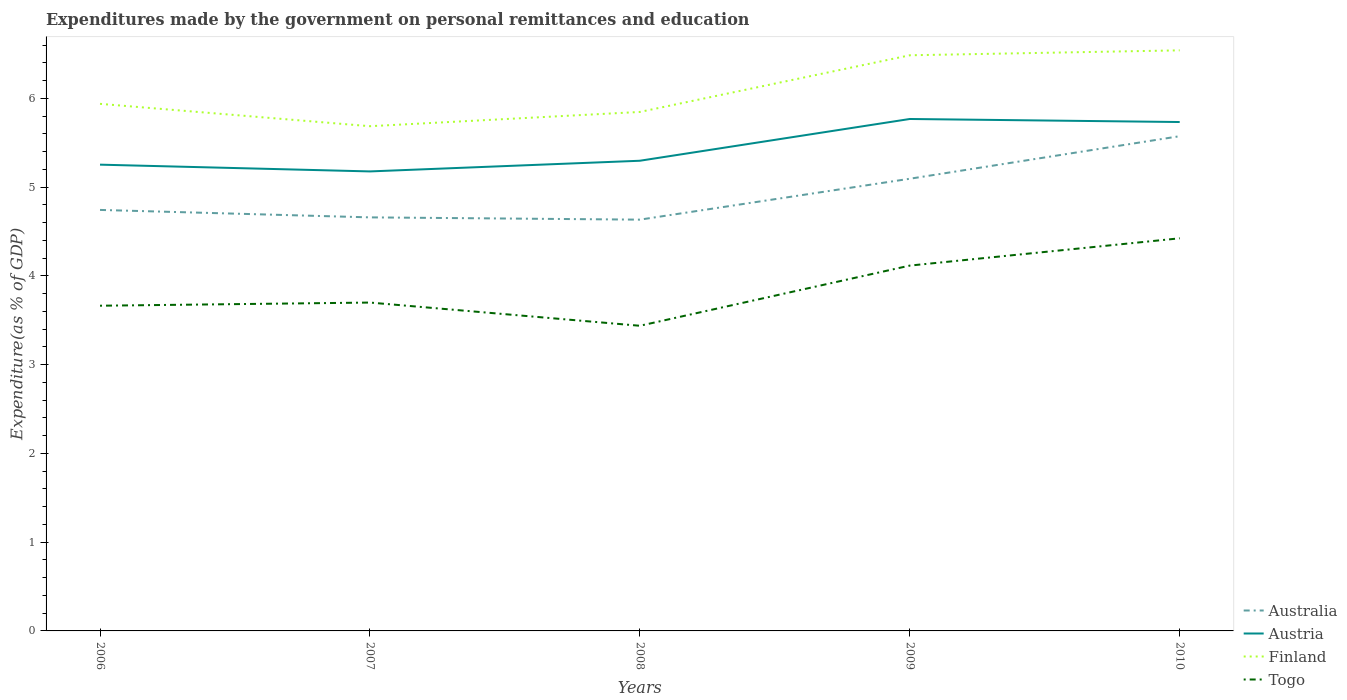How many different coloured lines are there?
Give a very brief answer. 4. Does the line corresponding to Austria intersect with the line corresponding to Togo?
Your answer should be compact. No. Is the number of lines equal to the number of legend labels?
Provide a short and direct response. Yes. Across all years, what is the maximum expenditures made by the government on personal remittances and education in Finland?
Ensure brevity in your answer.  5.69. In which year was the expenditures made by the government on personal remittances and education in Finland maximum?
Make the answer very short. 2007. What is the total expenditures made by the government on personal remittances and education in Finland in the graph?
Offer a very short reply. -0.6. What is the difference between the highest and the second highest expenditures made by the government on personal remittances and education in Australia?
Provide a succinct answer. 0.94. What is the difference between the highest and the lowest expenditures made by the government on personal remittances and education in Austria?
Provide a succinct answer. 2. How many lines are there?
Ensure brevity in your answer.  4. How many years are there in the graph?
Provide a succinct answer. 5. What is the difference between two consecutive major ticks on the Y-axis?
Offer a terse response. 1. Does the graph contain any zero values?
Your answer should be compact. No. Does the graph contain grids?
Provide a succinct answer. No. Where does the legend appear in the graph?
Your answer should be compact. Bottom right. How many legend labels are there?
Your response must be concise. 4. What is the title of the graph?
Provide a succinct answer. Expenditures made by the government on personal remittances and education. What is the label or title of the Y-axis?
Your answer should be compact. Expenditure(as % of GDP). What is the Expenditure(as % of GDP) of Australia in 2006?
Keep it short and to the point. 4.74. What is the Expenditure(as % of GDP) in Austria in 2006?
Provide a short and direct response. 5.25. What is the Expenditure(as % of GDP) of Finland in 2006?
Your answer should be compact. 5.94. What is the Expenditure(as % of GDP) in Togo in 2006?
Provide a short and direct response. 3.66. What is the Expenditure(as % of GDP) of Australia in 2007?
Your answer should be compact. 4.66. What is the Expenditure(as % of GDP) of Austria in 2007?
Offer a very short reply. 5.18. What is the Expenditure(as % of GDP) of Finland in 2007?
Give a very brief answer. 5.69. What is the Expenditure(as % of GDP) in Togo in 2007?
Provide a short and direct response. 3.7. What is the Expenditure(as % of GDP) in Australia in 2008?
Ensure brevity in your answer.  4.63. What is the Expenditure(as % of GDP) in Austria in 2008?
Offer a terse response. 5.3. What is the Expenditure(as % of GDP) of Finland in 2008?
Provide a succinct answer. 5.85. What is the Expenditure(as % of GDP) in Togo in 2008?
Give a very brief answer. 3.44. What is the Expenditure(as % of GDP) in Australia in 2009?
Your answer should be compact. 5.09. What is the Expenditure(as % of GDP) of Austria in 2009?
Make the answer very short. 5.77. What is the Expenditure(as % of GDP) of Finland in 2009?
Keep it short and to the point. 6.49. What is the Expenditure(as % of GDP) of Togo in 2009?
Your answer should be compact. 4.12. What is the Expenditure(as % of GDP) in Australia in 2010?
Offer a very short reply. 5.57. What is the Expenditure(as % of GDP) of Austria in 2010?
Keep it short and to the point. 5.73. What is the Expenditure(as % of GDP) in Finland in 2010?
Offer a terse response. 6.54. What is the Expenditure(as % of GDP) in Togo in 2010?
Give a very brief answer. 4.42. Across all years, what is the maximum Expenditure(as % of GDP) of Australia?
Your response must be concise. 5.57. Across all years, what is the maximum Expenditure(as % of GDP) of Austria?
Offer a very short reply. 5.77. Across all years, what is the maximum Expenditure(as % of GDP) in Finland?
Ensure brevity in your answer.  6.54. Across all years, what is the maximum Expenditure(as % of GDP) of Togo?
Offer a terse response. 4.42. Across all years, what is the minimum Expenditure(as % of GDP) of Australia?
Give a very brief answer. 4.63. Across all years, what is the minimum Expenditure(as % of GDP) in Austria?
Provide a succinct answer. 5.18. Across all years, what is the minimum Expenditure(as % of GDP) of Finland?
Provide a succinct answer. 5.69. Across all years, what is the minimum Expenditure(as % of GDP) in Togo?
Offer a terse response. 3.44. What is the total Expenditure(as % of GDP) of Australia in the graph?
Your answer should be compact. 24.7. What is the total Expenditure(as % of GDP) in Austria in the graph?
Give a very brief answer. 27.23. What is the total Expenditure(as % of GDP) in Finland in the graph?
Offer a very short reply. 30.5. What is the total Expenditure(as % of GDP) of Togo in the graph?
Your response must be concise. 19.34. What is the difference between the Expenditure(as % of GDP) in Australia in 2006 and that in 2007?
Keep it short and to the point. 0.08. What is the difference between the Expenditure(as % of GDP) in Austria in 2006 and that in 2007?
Your answer should be very brief. 0.08. What is the difference between the Expenditure(as % of GDP) of Finland in 2006 and that in 2007?
Give a very brief answer. 0.25. What is the difference between the Expenditure(as % of GDP) of Togo in 2006 and that in 2007?
Offer a very short reply. -0.04. What is the difference between the Expenditure(as % of GDP) of Australia in 2006 and that in 2008?
Make the answer very short. 0.11. What is the difference between the Expenditure(as % of GDP) in Austria in 2006 and that in 2008?
Your response must be concise. -0.04. What is the difference between the Expenditure(as % of GDP) in Finland in 2006 and that in 2008?
Provide a short and direct response. 0.09. What is the difference between the Expenditure(as % of GDP) in Togo in 2006 and that in 2008?
Offer a terse response. 0.23. What is the difference between the Expenditure(as % of GDP) in Australia in 2006 and that in 2009?
Your answer should be compact. -0.35. What is the difference between the Expenditure(as % of GDP) in Austria in 2006 and that in 2009?
Provide a short and direct response. -0.51. What is the difference between the Expenditure(as % of GDP) in Finland in 2006 and that in 2009?
Your answer should be compact. -0.55. What is the difference between the Expenditure(as % of GDP) in Togo in 2006 and that in 2009?
Make the answer very short. -0.45. What is the difference between the Expenditure(as % of GDP) in Australia in 2006 and that in 2010?
Keep it short and to the point. -0.83. What is the difference between the Expenditure(as % of GDP) of Austria in 2006 and that in 2010?
Provide a succinct answer. -0.48. What is the difference between the Expenditure(as % of GDP) in Finland in 2006 and that in 2010?
Keep it short and to the point. -0.6. What is the difference between the Expenditure(as % of GDP) in Togo in 2006 and that in 2010?
Offer a terse response. -0.76. What is the difference between the Expenditure(as % of GDP) of Australia in 2007 and that in 2008?
Provide a short and direct response. 0.03. What is the difference between the Expenditure(as % of GDP) of Austria in 2007 and that in 2008?
Give a very brief answer. -0.12. What is the difference between the Expenditure(as % of GDP) in Finland in 2007 and that in 2008?
Ensure brevity in your answer.  -0.16. What is the difference between the Expenditure(as % of GDP) in Togo in 2007 and that in 2008?
Offer a very short reply. 0.26. What is the difference between the Expenditure(as % of GDP) in Australia in 2007 and that in 2009?
Your answer should be very brief. -0.44. What is the difference between the Expenditure(as % of GDP) in Austria in 2007 and that in 2009?
Give a very brief answer. -0.59. What is the difference between the Expenditure(as % of GDP) in Finland in 2007 and that in 2009?
Keep it short and to the point. -0.8. What is the difference between the Expenditure(as % of GDP) in Togo in 2007 and that in 2009?
Offer a terse response. -0.42. What is the difference between the Expenditure(as % of GDP) of Australia in 2007 and that in 2010?
Offer a terse response. -0.91. What is the difference between the Expenditure(as % of GDP) in Austria in 2007 and that in 2010?
Make the answer very short. -0.56. What is the difference between the Expenditure(as % of GDP) of Finland in 2007 and that in 2010?
Offer a terse response. -0.85. What is the difference between the Expenditure(as % of GDP) of Togo in 2007 and that in 2010?
Offer a very short reply. -0.72. What is the difference between the Expenditure(as % of GDP) of Australia in 2008 and that in 2009?
Provide a short and direct response. -0.46. What is the difference between the Expenditure(as % of GDP) of Austria in 2008 and that in 2009?
Provide a short and direct response. -0.47. What is the difference between the Expenditure(as % of GDP) in Finland in 2008 and that in 2009?
Ensure brevity in your answer.  -0.64. What is the difference between the Expenditure(as % of GDP) in Togo in 2008 and that in 2009?
Keep it short and to the point. -0.68. What is the difference between the Expenditure(as % of GDP) in Australia in 2008 and that in 2010?
Make the answer very short. -0.94. What is the difference between the Expenditure(as % of GDP) in Austria in 2008 and that in 2010?
Ensure brevity in your answer.  -0.44. What is the difference between the Expenditure(as % of GDP) in Finland in 2008 and that in 2010?
Your response must be concise. -0.69. What is the difference between the Expenditure(as % of GDP) of Togo in 2008 and that in 2010?
Provide a short and direct response. -0.99. What is the difference between the Expenditure(as % of GDP) of Australia in 2009 and that in 2010?
Ensure brevity in your answer.  -0.48. What is the difference between the Expenditure(as % of GDP) of Austria in 2009 and that in 2010?
Your answer should be very brief. 0.03. What is the difference between the Expenditure(as % of GDP) of Finland in 2009 and that in 2010?
Offer a very short reply. -0.06. What is the difference between the Expenditure(as % of GDP) in Togo in 2009 and that in 2010?
Make the answer very short. -0.31. What is the difference between the Expenditure(as % of GDP) in Australia in 2006 and the Expenditure(as % of GDP) in Austria in 2007?
Give a very brief answer. -0.43. What is the difference between the Expenditure(as % of GDP) in Australia in 2006 and the Expenditure(as % of GDP) in Finland in 2007?
Your answer should be very brief. -0.94. What is the difference between the Expenditure(as % of GDP) in Australia in 2006 and the Expenditure(as % of GDP) in Togo in 2007?
Your answer should be very brief. 1.04. What is the difference between the Expenditure(as % of GDP) of Austria in 2006 and the Expenditure(as % of GDP) of Finland in 2007?
Your answer should be very brief. -0.43. What is the difference between the Expenditure(as % of GDP) in Austria in 2006 and the Expenditure(as % of GDP) in Togo in 2007?
Give a very brief answer. 1.55. What is the difference between the Expenditure(as % of GDP) of Finland in 2006 and the Expenditure(as % of GDP) of Togo in 2007?
Ensure brevity in your answer.  2.24. What is the difference between the Expenditure(as % of GDP) of Australia in 2006 and the Expenditure(as % of GDP) of Austria in 2008?
Make the answer very short. -0.55. What is the difference between the Expenditure(as % of GDP) in Australia in 2006 and the Expenditure(as % of GDP) in Finland in 2008?
Your response must be concise. -1.1. What is the difference between the Expenditure(as % of GDP) of Australia in 2006 and the Expenditure(as % of GDP) of Togo in 2008?
Your answer should be compact. 1.31. What is the difference between the Expenditure(as % of GDP) in Austria in 2006 and the Expenditure(as % of GDP) in Finland in 2008?
Give a very brief answer. -0.59. What is the difference between the Expenditure(as % of GDP) of Austria in 2006 and the Expenditure(as % of GDP) of Togo in 2008?
Make the answer very short. 1.82. What is the difference between the Expenditure(as % of GDP) in Finland in 2006 and the Expenditure(as % of GDP) in Togo in 2008?
Ensure brevity in your answer.  2.5. What is the difference between the Expenditure(as % of GDP) in Australia in 2006 and the Expenditure(as % of GDP) in Austria in 2009?
Your response must be concise. -1.02. What is the difference between the Expenditure(as % of GDP) in Australia in 2006 and the Expenditure(as % of GDP) in Finland in 2009?
Keep it short and to the point. -1.74. What is the difference between the Expenditure(as % of GDP) in Australia in 2006 and the Expenditure(as % of GDP) in Togo in 2009?
Your answer should be very brief. 0.63. What is the difference between the Expenditure(as % of GDP) of Austria in 2006 and the Expenditure(as % of GDP) of Finland in 2009?
Ensure brevity in your answer.  -1.23. What is the difference between the Expenditure(as % of GDP) of Austria in 2006 and the Expenditure(as % of GDP) of Togo in 2009?
Provide a short and direct response. 1.14. What is the difference between the Expenditure(as % of GDP) of Finland in 2006 and the Expenditure(as % of GDP) of Togo in 2009?
Provide a succinct answer. 1.82. What is the difference between the Expenditure(as % of GDP) in Australia in 2006 and the Expenditure(as % of GDP) in Austria in 2010?
Give a very brief answer. -0.99. What is the difference between the Expenditure(as % of GDP) of Australia in 2006 and the Expenditure(as % of GDP) of Finland in 2010?
Your response must be concise. -1.8. What is the difference between the Expenditure(as % of GDP) in Australia in 2006 and the Expenditure(as % of GDP) in Togo in 2010?
Offer a very short reply. 0.32. What is the difference between the Expenditure(as % of GDP) of Austria in 2006 and the Expenditure(as % of GDP) of Finland in 2010?
Offer a very short reply. -1.29. What is the difference between the Expenditure(as % of GDP) of Austria in 2006 and the Expenditure(as % of GDP) of Togo in 2010?
Your answer should be very brief. 0.83. What is the difference between the Expenditure(as % of GDP) in Finland in 2006 and the Expenditure(as % of GDP) in Togo in 2010?
Make the answer very short. 1.51. What is the difference between the Expenditure(as % of GDP) of Australia in 2007 and the Expenditure(as % of GDP) of Austria in 2008?
Offer a terse response. -0.64. What is the difference between the Expenditure(as % of GDP) of Australia in 2007 and the Expenditure(as % of GDP) of Finland in 2008?
Give a very brief answer. -1.19. What is the difference between the Expenditure(as % of GDP) in Australia in 2007 and the Expenditure(as % of GDP) in Togo in 2008?
Make the answer very short. 1.22. What is the difference between the Expenditure(as % of GDP) in Austria in 2007 and the Expenditure(as % of GDP) in Finland in 2008?
Ensure brevity in your answer.  -0.67. What is the difference between the Expenditure(as % of GDP) in Austria in 2007 and the Expenditure(as % of GDP) in Togo in 2008?
Give a very brief answer. 1.74. What is the difference between the Expenditure(as % of GDP) of Finland in 2007 and the Expenditure(as % of GDP) of Togo in 2008?
Make the answer very short. 2.25. What is the difference between the Expenditure(as % of GDP) of Australia in 2007 and the Expenditure(as % of GDP) of Austria in 2009?
Give a very brief answer. -1.11. What is the difference between the Expenditure(as % of GDP) of Australia in 2007 and the Expenditure(as % of GDP) of Finland in 2009?
Provide a short and direct response. -1.83. What is the difference between the Expenditure(as % of GDP) of Australia in 2007 and the Expenditure(as % of GDP) of Togo in 2009?
Offer a terse response. 0.54. What is the difference between the Expenditure(as % of GDP) in Austria in 2007 and the Expenditure(as % of GDP) in Finland in 2009?
Your answer should be compact. -1.31. What is the difference between the Expenditure(as % of GDP) of Austria in 2007 and the Expenditure(as % of GDP) of Togo in 2009?
Keep it short and to the point. 1.06. What is the difference between the Expenditure(as % of GDP) in Finland in 2007 and the Expenditure(as % of GDP) in Togo in 2009?
Keep it short and to the point. 1.57. What is the difference between the Expenditure(as % of GDP) in Australia in 2007 and the Expenditure(as % of GDP) in Austria in 2010?
Offer a terse response. -1.07. What is the difference between the Expenditure(as % of GDP) of Australia in 2007 and the Expenditure(as % of GDP) of Finland in 2010?
Make the answer very short. -1.88. What is the difference between the Expenditure(as % of GDP) of Australia in 2007 and the Expenditure(as % of GDP) of Togo in 2010?
Offer a very short reply. 0.24. What is the difference between the Expenditure(as % of GDP) in Austria in 2007 and the Expenditure(as % of GDP) in Finland in 2010?
Make the answer very short. -1.36. What is the difference between the Expenditure(as % of GDP) of Austria in 2007 and the Expenditure(as % of GDP) of Togo in 2010?
Provide a succinct answer. 0.75. What is the difference between the Expenditure(as % of GDP) of Finland in 2007 and the Expenditure(as % of GDP) of Togo in 2010?
Provide a short and direct response. 1.26. What is the difference between the Expenditure(as % of GDP) of Australia in 2008 and the Expenditure(as % of GDP) of Austria in 2009?
Ensure brevity in your answer.  -1.13. What is the difference between the Expenditure(as % of GDP) of Australia in 2008 and the Expenditure(as % of GDP) of Finland in 2009?
Offer a terse response. -1.85. What is the difference between the Expenditure(as % of GDP) of Australia in 2008 and the Expenditure(as % of GDP) of Togo in 2009?
Your answer should be compact. 0.52. What is the difference between the Expenditure(as % of GDP) in Austria in 2008 and the Expenditure(as % of GDP) in Finland in 2009?
Your answer should be compact. -1.19. What is the difference between the Expenditure(as % of GDP) in Austria in 2008 and the Expenditure(as % of GDP) in Togo in 2009?
Give a very brief answer. 1.18. What is the difference between the Expenditure(as % of GDP) in Finland in 2008 and the Expenditure(as % of GDP) in Togo in 2009?
Keep it short and to the point. 1.73. What is the difference between the Expenditure(as % of GDP) of Australia in 2008 and the Expenditure(as % of GDP) of Austria in 2010?
Keep it short and to the point. -1.1. What is the difference between the Expenditure(as % of GDP) in Australia in 2008 and the Expenditure(as % of GDP) in Finland in 2010?
Provide a succinct answer. -1.91. What is the difference between the Expenditure(as % of GDP) of Australia in 2008 and the Expenditure(as % of GDP) of Togo in 2010?
Give a very brief answer. 0.21. What is the difference between the Expenditure(as % of GDP) in Austria in 2008 and the Expenditure(as % of GDP) in Finland in 2010?
Give a very brief answer. -1.24. What is the difference between the Expenditure(as % of GDP) of Austria in 2008 and the Expenditure(as % of GDP) of Togo in 2010?
Keep it short and to the point. 0.87. What is the difference between the Expenditure(as % of GDP) of Finland in 2008 and the Expenditure(as % of GDP) of Togo in 2010?
Make the answer very short. 1.42. What is the difference between the Expenditure(as % of GDP) of Australia in 2009 and the Expenditure(as % of GDP) of Austria in 2010?
Offer a terse response. -0.64. What is the difference between the Expenditure(as % of GDP) of Australia in 2009 and the Expenditure(as % of GDP) of Finland in 2010?
Your response must be concise. -1.45. What is the difference between the Expenditure(as % of GDP) of Australia in 2009 and the Expenditure(as % of GDP) of Togo in 2010?
Offer a very short reply. 0.67. What is the difference between the Expenditure(as % of GDP) in Austria in 2009 and the Expenditure(as % of GDP) in Finland in 2010?
Give a very brief answer. -0.77. What is the difference between the Expenditure(as % of GDP) of Austria in 2009 and the Expenditure(as % of GDP) of Togo in 2010?
Ensure brevity in your answer.  1.34. What is the difference between the Expenditure(as % of GDP) of Finland in 2009 and the Expenditure(as % of GDP) of Togo in 2010?
Keep it short and to the point. 2.06. What is the average Expenditure(as % of GDP) in Australia per year?
Your answer should be compact. 4.94. What is the average Expenditure(as % of GDP) of Austria per year?
Keep it short and to the point. 5.45. What is the average Expenditure(as % of GDP) of Finland per year?
Your answer should be very brief. 6.1. What is the average Expenditure(as % of GDP) in Togo per year?
Provide a short and direct response. 3.87. In the year 2006, what is the difference between the Expenditure(as % of GDP) of Australia and Expenditure(as % of GDP) of Austria?
Make the answer very short. -0.51. In the year 2006, what is the difference between the Expenditure(as % of GDP) of Australia and Expenditure(as % of GDP) of Finland?
Offer a terse response. -1.2. In the year 2006, what is the difference between the Expenditure(as % of GDP) of Australia and Expenditure(as % of GDP) of Togo?
Provide a succinct answer. 1.08. In the year 2006, what is the difference between the Expenditure(as % of GDP) in Austria and Expenditure(as % of GDP) in Finland?
Your response must be concise. -0.69. In the year 2006, what is the difference between the Expenditure(as % of GDP) in Austria and Expenditure(as % of GDP) in Togo?
Your answer should be very brief. 1.59. In the year 2006, what is the difference between the Expenditure(as % of GDP) of Finland and Expenditure(as % of GDP) of Togo?
Ensure brevity in your answer.  2.27. In the year 2007, what is the difference between the Expenditure(as % of GDP) in Australia and Expenditure(as % of GDP) in Austria?
Your answer should be compact. -0.52. In the year 2007, what is the difference between the Expenditure(as % of GDP) in Australia and Expenditure(as % of GDP) in Finland?
Your answer should be compact. -1.03. In the year 2007, what is the difference between the Expenditure(as % of GDP) of Australia and Expenditure(as % of GDP) of Togo?
Give a very brief answer. 0.96. In the year 2007, what is the difference between the Expenditure(as % of GDP) in Austria and Expenditure(as % of GDP) in Finland?
Make the answer very short. -0.51. In the year 2007, what is the difference between the Expenditure(as % of GDP) of Austria and Expenditure(as % of GDP) of Togo?
Offer a terse response. 1.48. In the year 2007, what is the difference between the Expenditure(as % of GDP) in Finland and Expenditure(as % of GDP) in Togo?
Give a very brief answer. 1.99. In the year 2008, what is the difference between the Expenditure(as % of GDP) in Australia and Expenditure(as % of GDP) in Austria?
Ensure brevity in your answer.  -0.66. In the year 2008, what is the difference between the Expenditure(as % of GDP) in Australia and Expenditure(as % of GDP) in Finland?
Make the answer very short. -1.21. In the year 2008, what is the difference between the Expenditure(as % of GDP) in Australia and Expenditure(as % of GDP) in Togo?
Keep it short and to the point. 1.2. In the year 2008, what is the difference between the Expenditure(as % of GDP) in Austria and Expenditure(as % of GDP) in Finland?
Offer a terse response. -0.55. In the year 2008, what is the difference between the Expenditure(as % of GDP) in Austria and Expenditure(as % of GDP) in Togo?
Give a very brief answer. 1.86. In the year 2008, what is the difference between the Expenditure(as % of GDP) in Finland and Expenditure(as % of GDP) in Togo?
Make the answer very short. 2.41. In the year 2009, what is the difference between the Expenditure(as % of GDP) in Australia and Expenditure(as % of GDP) in Austria?
Keep it short and to the point. -0.67. In the year 2009, what is the difference between the Expenditure(as % of GDP) in Australia and Expenditure(as % of GDP) in Finland?
Offer a terse response. -1.39. In the year 2009, what is the difference between the Expenditure(as % of GDP) in Australia and Expenditure(as % of GDP) in Togo?
Your answer should be very brief. 0.98. In the year 2009, what is the difference between the Expenditure(as % of GDP) of Austria and Expenditure(as % of GDP) of Finland?
Your answer should be compact. -0.72. In the year 2009, what is the difference between the Expenditure(as % of GDP) of Austria and Expenditure(as % of GDP) of Togo?
Your answer should be very brief. 1.65. In the year 2009, what is the difference between the Expenditure(as % of GDP) in Finland and Expenditure(as % of GDP) in Togo?
Make the answer very short. 2.37. In the year 2010, what is the difference between the Expenditure(as % of GDP) of Australia and Expenditure(as % of GDP) of Austria?
Provide a succinct answer. -0.16. In the year 2010, what is the difference between the Expenditure(as % of GDP) of Australia and Expenditure(as % of GDP) of Finland?
Provide a succinct answer. -0.97. In the year 2010, what is the difference between the Expenditure(as % of GDP) in Australia and Expenditure(as % of GDP) in Togo?
Keep it short and to the point. 1.15. In the year 2010, what is the difference between the Expenditure(as % of GDP) of Austria and Expenditure(as % of GDP) of Finland?
Make the answer very short. -0.81. In the year 2010, what is the difference between the Expenditure(as % of GDP) in Austria and Expenditure(as % of GDP) in Togo?
Keep it short and to the point. 1.31. In the year 2010, what is the difference between the Expenditure(as % of GDP) in Finland and Expenditure(as % of GDP) in Togo?
Provide a succinct answer. 2.12. What is the ratio of the Expenditure(as % of GDP) of Australia in 2006 to that in 2007?
Provide a short and direct response. 1.02. What is the ratio of the Expenditure(as % of GDP) of Austria in 2006 to that in 2007?
Offer a very short reply. 1.01. What is the ratio of the Expenditure(as % of GDP) of Finland in 2006 to that in 2007?
Make the answer very short. 1.04. What is the ratio of the Expenditure(as % of GDP) in Togo in 2006 to that in 2007?
Your answer should be compact. 0.99. What is the ratio of the Expenditure(as % of GDP) in Australia in 2006 to that in 2008?
Offer a very short reply. 1.02. What is the ratio of the Expenditure(as % of GDP) in Finland in 2006 to that in 2008?
Provide a short and direct response. 1.02. What is the ratio of the Expenditure(as % of GDP) in Togo in 2006 to that in 2008?
Make the answer very short. 1.07. What is the ratio of the Expenditure(as % of GDP) of Australia in 2006 to that in 2009?
Provide a succinct answer. 0.93. What is the ratio of the Expenditure(as % of GDP) of Austria in 2006 to that in 2009?
Ensure brevity in your answer.  0.91. What is the ratio of the Expenditure(as % of GDP) of Finland in 2006 to that in 2009?
Give a very brief answer. 0.92. What is the ratio of the Expenditure(as % of GDP) in Togo in 2006 to that in 2009?
Provide a short and direct response. 0.89. What is the ratio of the Expenditure(as % of GDP) of Australia in 2006 to that in 2010?
Provide a short and direct response. 0.85. What is the ratio of the Expenditure(as % of GDP) of Austria in 2006 to that in 2010?
Give a very brief answer. 0.92. What is the ratio of the Expenditure(as % of GDP) in Finland in 2006 to that in 2010?
Offer a terse response. 0.91. What is the ratio of the Expenditure(as % of GDP) in Togo in 2006 to that in 2010?
Provide a succinct answer. 0.83. What is the ratio of the Expenditure(as % of GDP) in Austria in 2007 to that in 2008?
Offer a terse response. 0.98. What is the ratio of the Expenditure(as % of GDP) in Finland in 2007 to that in 2008?
Your answer should be compact. 0.97. What is the ratio of the Expenditure(as % of GDP) in Togo in 2007 to that in 2008?
Offer a terse response. 1.08. What is the ratio of the Expenditure(as % of GDP) in Australia in 2007 to that in 2009?
Your answer should be very brief. 0.91. What is the ratio of the Expenditure(as % of GDP) in Austria in 2007 to that in 2009?
Offer a terse response. 0.9. What is the ratio of the Expenditure(as % of GDP) of Finland in 2007 to that in 2009?
Offer a very short reply. 0.88. What is the ratio of the Expenditure(as % of GDP) in Togo in 2007 to that in 2009?
Your response must be concise. 0.9. What is the ratio of the Expenditure(as % of GDP) of Australia in 2007 to that in 2010?
Ensure brevity in your answer.  0.84. What is the ratio of the Expenditure(as % of GDP) in Austria in 2007 to that in 2010?
Your answer should be compact. 0.9. What is the ratio of the Expenditure(as % of GDP) of Finland in 2007 to that in 2010?
Make the answer very short. 0.87. What is the ratio of the Expenditure(as % of GDP) in Togo in 2007 to that in 2010?
Keep it short and to the point. 0.84. What is the ratio of the Expenditure(as % of GDP) of Australia in 2008 to that in 2009?
Ensure brevity in your answer.  0.91. What is the ratio of the Expenditure(as % of GDP) of Austria in 2008 to that in 2009?
Your response must be concise. 0.92. What is the ratio of the Expenditure(as % of GDP) of Finland in 2008 to that in 2009?
Make the answer very short. 0.9. What is the ratio of the Expenditure(as % of GDP) in Togo in 2008 to that in 2009?
Offer a terse response. 0.84. What is the ratio of the Expenditure(as % of GDP) of Australia in 2008 to that in 2010?
Provide a succinct answer. 0.83. What is the ratio of the Expenditure(as % of GDP) of Austria in 2008 to that in 2010?
Your answer should be compact. 0.92. What is the ratio of the Expenditure(as % of GDP) of Finland in 2008 to that in 2010?
Keep it short and to the point. 0.89. What is the ratio of the Expenditure(as % of GDP) of Togo in 2008 to that in 2010?
Give a very brief answer. 0.78. What is the ratio of the Expenditure(as % of GDP) in Australia in 2009 to that in 2010?
Your response must be concise. 0.91. What is the ratio of the Expenditure(as % of GDP) in Togo in 2009 to that in 2010?
Offer a very short reply. 0.93. What is the difference between the highest and the second highest Expenditure(as % of GDP) in Australia?
Provide a succinct answer. 0.48. What is the difference between the highest and the second highest Expenditure(as % of GDP) of Austria?
Ensure brevity in your answer.  0.03. What is the difference between the highest and the second highest Expenditure(as % of GDP) of Finland?
Provide a short and direct response. 0.06. What is the difference between the highest and the second highest Expenditure(as % of GDP) of Togo?
Keep it short and to the point. 0.31. What is the difference between the highest and the lowest Expenditure(as % of GDP) in Australia?
Your answer should be compact. 0.94. What is the difference between the highest and the lowest Expenditure(as % of GDP) in Austria?
Give a very brief answer. 0.59. What is the difference between the highest and the lowest Expenditure(as % of GDP) of Finland?
Make the answer very short. 0.85. What is the difference between the highest and the lowest Expenditure(as % of GDP) in Togo?
Keep it short and to the point. 0.99. 